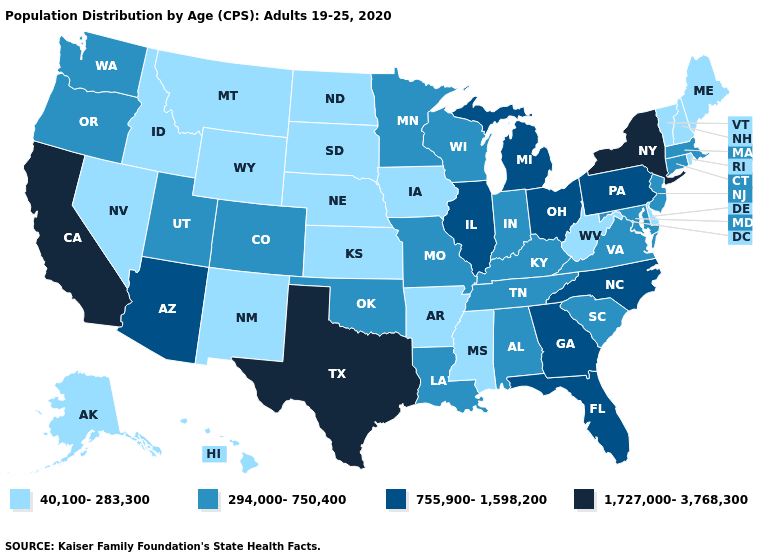What is the lowest value in the MidWest?
Answer briefly. 40,100-283,300. Does Michigan have the highest value in the MidWest?
Be succinct. Yes. What is the value of Montana?
Be succinct. 40,100-283,300. Name the states that have a value in the range 40,100-283,300?
Be succinct. Alaska, Arkansas, Delaware, Hawaii, Idaho, Iowa, Kansas, Maine, Mississippi, Montana, Nebraska, Nevada, New Hampshire, New Mexico, North Dakota, Rhode Island, South Dakota, Vermont, West Virginia, Wyoming. Which states have the highest value in the USA?
Answer briefly. California, New York, Texas. What is the value of Maine?
Keep it brief. 40,100-283,300. Does Nevada have the same value as Vermont?
Be succinct. Yes. What is the lowest value in states that border Michigan?
Be succinct. 294,000-750,400. Name the states that have a value in the range 294,000-750,400?
Write a very short answer. Alabama, Colorado, Connecticut, Indiana, Kentucky, Louisiana, Maryland, Massachusetts, Minnesota, Missouri, New Jersey, Oklahoma, Oregon, South Carolina, Tennessee, Utah, Virginia, Washington, Wisconsin. Does the map have missing data?
Give a very brief answer. No. What is the highest value in states that border Wyoming?
Write a very short answer. 294,000-750,400. Does the first symbol in the legend represent the smallest category?
Concise answer only. Yes. Does Georgia have a higher value than South Carolina?
Be succinct. Yes. Does Virginia have the lowest value in the South?
Short answer required. No. What is the value of Alabama?
Concise answer only. 294,000-750,400. 